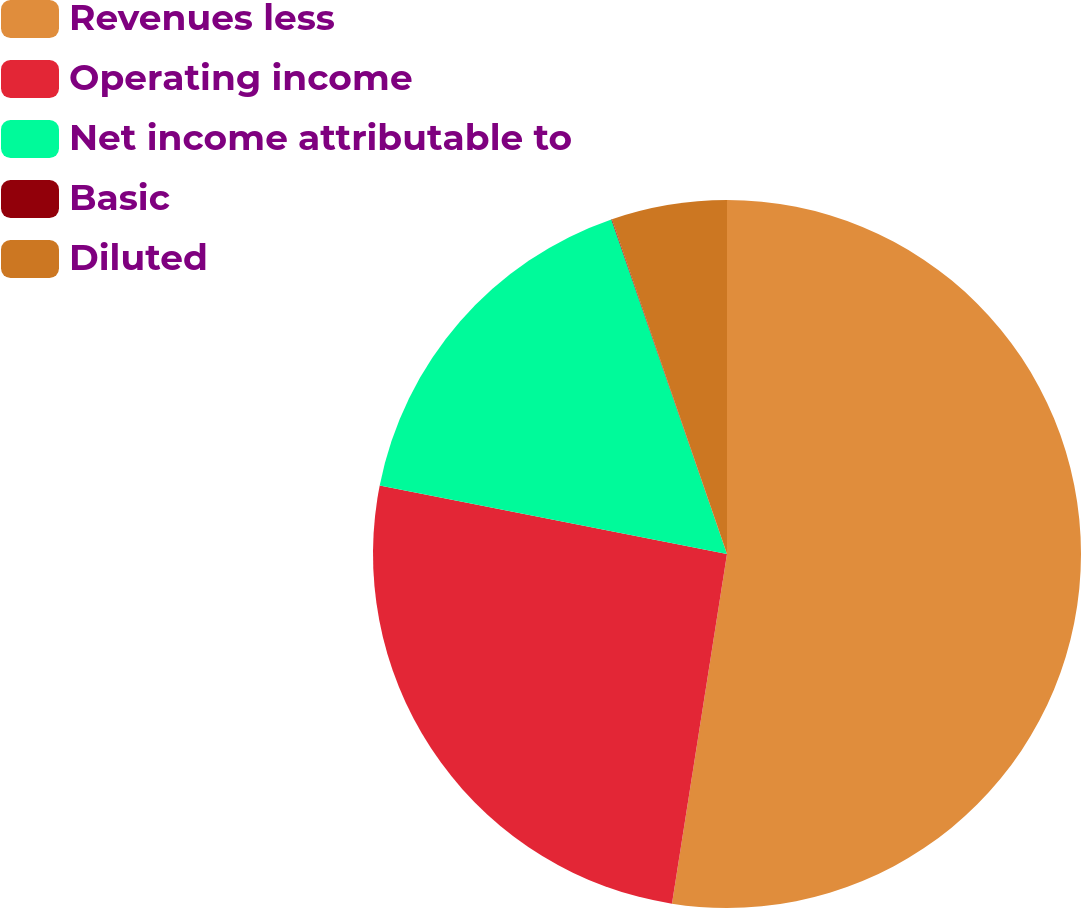Convert chart. <chart><loc_0><loc_0><loc_500><loc_500><pie_chart><fcel>Revenues less<fcel>Operating income<fcel>Net income attributable to<fcel>Basic<fcel>Diluted<nl><fcel>52.49%<fcel>25.62%<fcel>16.6%<fcel>0.03%<fcel>5.27%<nl></chart> 